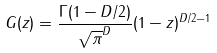Convert formula to latex. <formula><loc_0><loc_0><loc_500><loc_500>G ( z ) = \frac { \Gamma ( 1 - D / 2 ) } { \sqrt { \pi } ^ { D } } ( 1 - z ) ^ { D / 2 - 1 }</formula> 